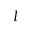Convert formula to latex. <formula><loc_0><loc_0><loc_500><loc_500>I</formula> 